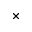Convert formula to latex. <formula><loc_0><loc_0><loc_500><loc_500>\times</formula> 